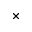Convert formula to latex. <formula><loc_0><loc_0><loc_500><loc_500>\times</formula> 